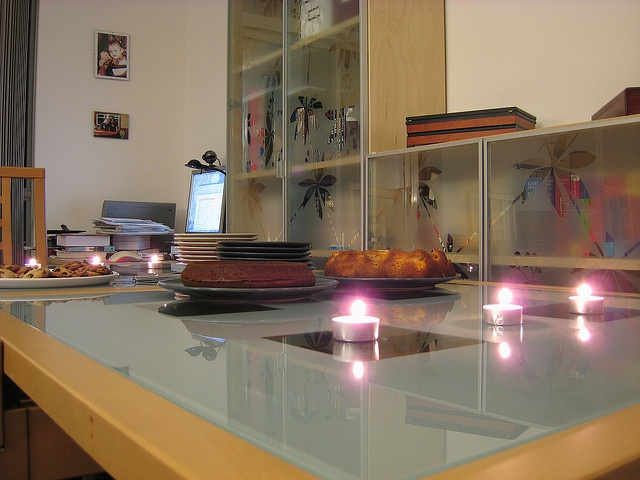Describe the objects in this image and their specific colors. I can see dining table in darkgreen, gray, and darkgray tones, cake in darkgreen, brown, and maroon tones, cake in darkgreen, maroon, black, brown, and gray tones, book in darkgreen, brown, black, and maroon tones, and chair in darkgreen, brown, maroon, and gray tones in this image. 